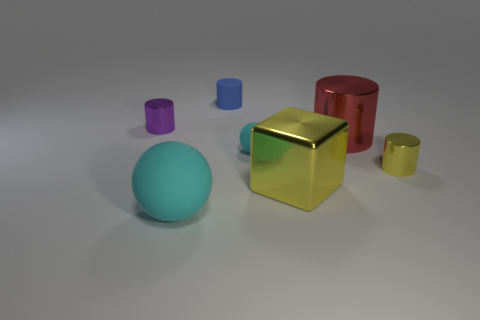What number of big objects are either purple blocks or blue objects? Within the image, there are a total of two large objects that fulfill the criteria: one large purple block and one large blue sphere. 